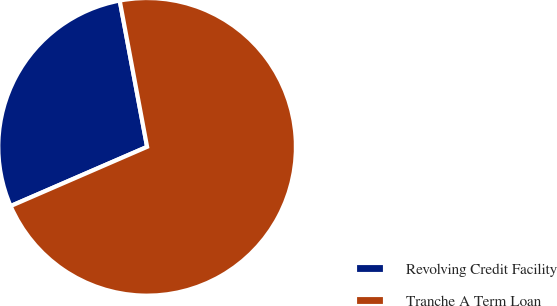<chart> <loc_0><loc_0><loc_500><loc_500><pie_chart><fcel>Revolving Credit Facility<fcel>Tranche A Term Loan<nl><fcel>28.57%<fcel>71.43%<nl></chart> 